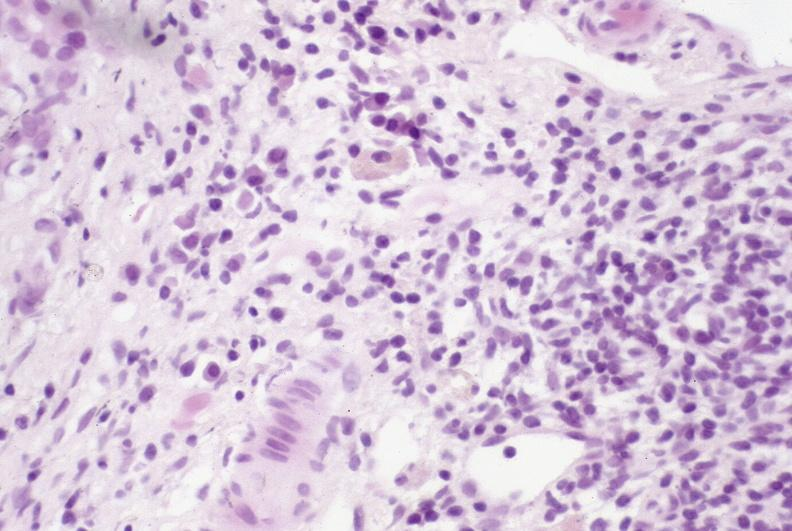does this image show primary sclerosing cholangitis?
Answer the question using a single word or phrase. Yes 